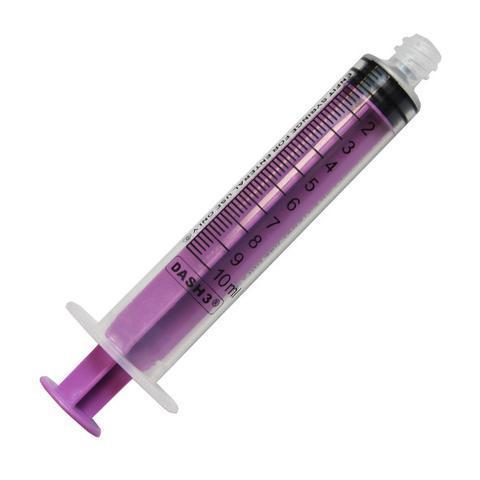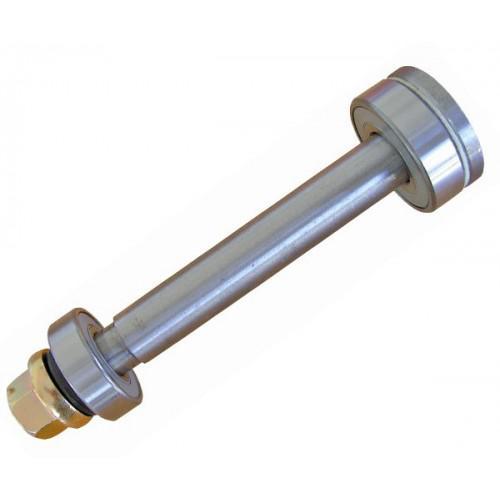The first image is the image on the left, the second image is the image on the right. For the images displayed, is the sentence "The syringe is marked to contain up to 60ml." factually correct? Answer yes or no. No. 